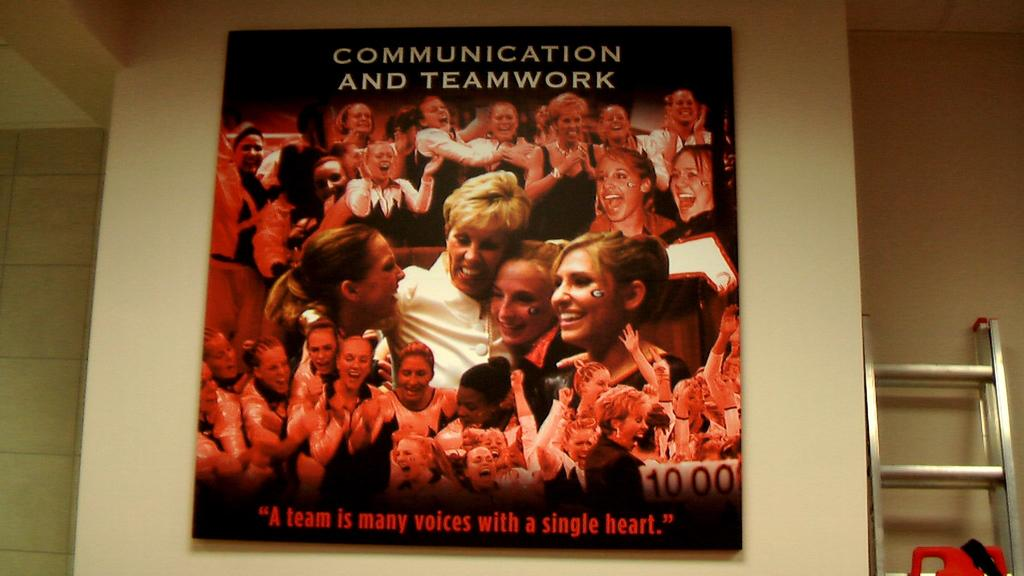Provide a one-sentence caption for the provided image. The poster features the catchphrase "A team is many voices with a single heart". 